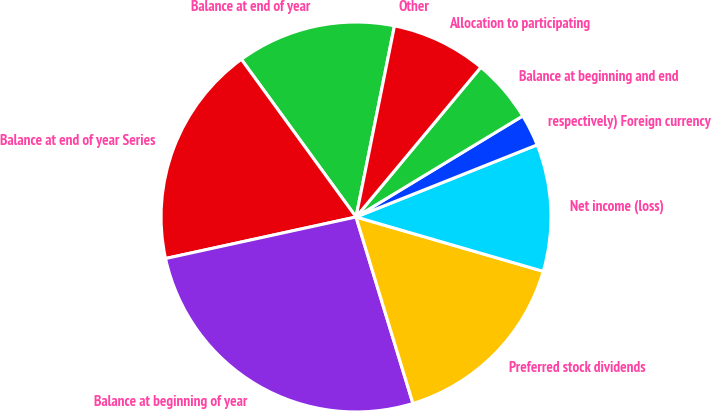Convert chart. <chart><loc_0><loc_0><loc_500><loc_500><pie_chart><fcel>Other<fcel>Balance at end of year<fcel>Balance at end of year Series<fcel>Balance at beginning of year<fcel>Preferred stock dividends<fcel>Net income (loss)<fcel>respectively) Foreign currency<fcel>Balance at beginning and end<fcel>Allocation to participating<nl><fcel>0.01%<fcel>13.16%<fcel>18.41%<fcel>26.3%<fcel>15.79%<fcel>10.53%<fcel>2.64%<fcel>5.27%<fcel>7.9%<nl></chart> 